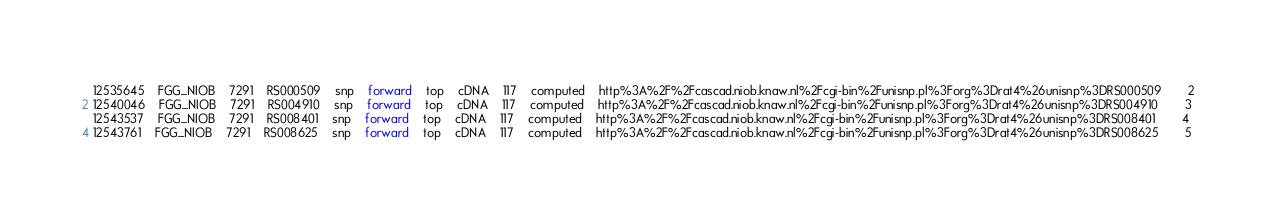Convert code to text. <code><loc_0><loc_0><loc_500><loc_500><_SQL_>12535645	FGG_NIOB	7291	RS000509	snp	forward	top	cDNA	117	computed	http%3A%2F%2Fcascad.niob.knaw.nl%2Fcgi-bin%2Funisnp.pl%3Forg%3Drat4%26unisnp%3DRS000509		2
12540046	FGG_NIOB	7291	RS004910	snp	forward	top	cDNA	117	computed	http%3A%2F%2Fcascad.niob.knaw.nl%2Fcgi-bin%2Funisnp.pl%3Forg%3Drat4%26unisnp%3DRS004910		3
12543537	FGG_NIOB	7291	RS008401	snp	forward	top	cDNA	117	computed	http%3A%2F%2Fcascad.niob.knaw.nl%2Fcgi-bin%2Funisnp.pl%3Forg%3Drat4%26unisnp%3DRS008401		4
12543761	FGG_NIOB	7291	RS008625	snp	forward	top	cDNA	117	computed	http%3A%2F%2Fcascad.niob.knaw.nl%2Fcgi-bin%2Funisnp.pl%3Forg%3Drat4%26unisnp%3DRS008625		5</code> 